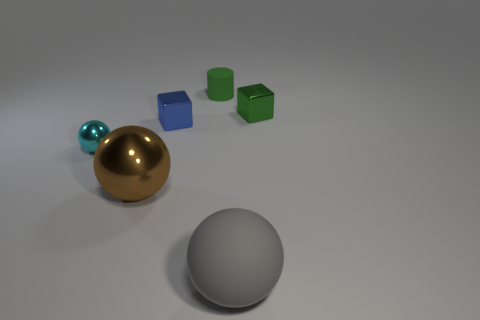Add 1 green objects. How many objects exist? 7 Subtract 1 green cylinders. How many objects are left? 5 Subtract all blocks. How many objects are left? 4 Subtract 1 cylinders. How many cylinders are left? 0 Subtract all brown cylinders. Subtract all blue balls. How many cylinders are left? 1 Subtract all gray blocks. How many brown cylinders are left? 0 Subtract all blue rubber things. Subtract all cyan objects. How many objects are left? 5 Add 3 cyan shiny things. How many cyan shiny things are left? 4 Add 5 blue things. How many blue things exist? 6 Subtract all green blocks. How many blocks are left? 1 